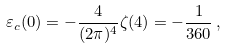Convert formula to latex. <formula><loc_0><loc_0><loc_500><loc_500>\varepsilon _ { c } ( 0 ) = - \frac { 4 } { ( 2 \pi ) ^ { 4 } } \zeta ( 4 ) = - { \frac { 1 } { 3 6 0 } } \, ,</formula> 